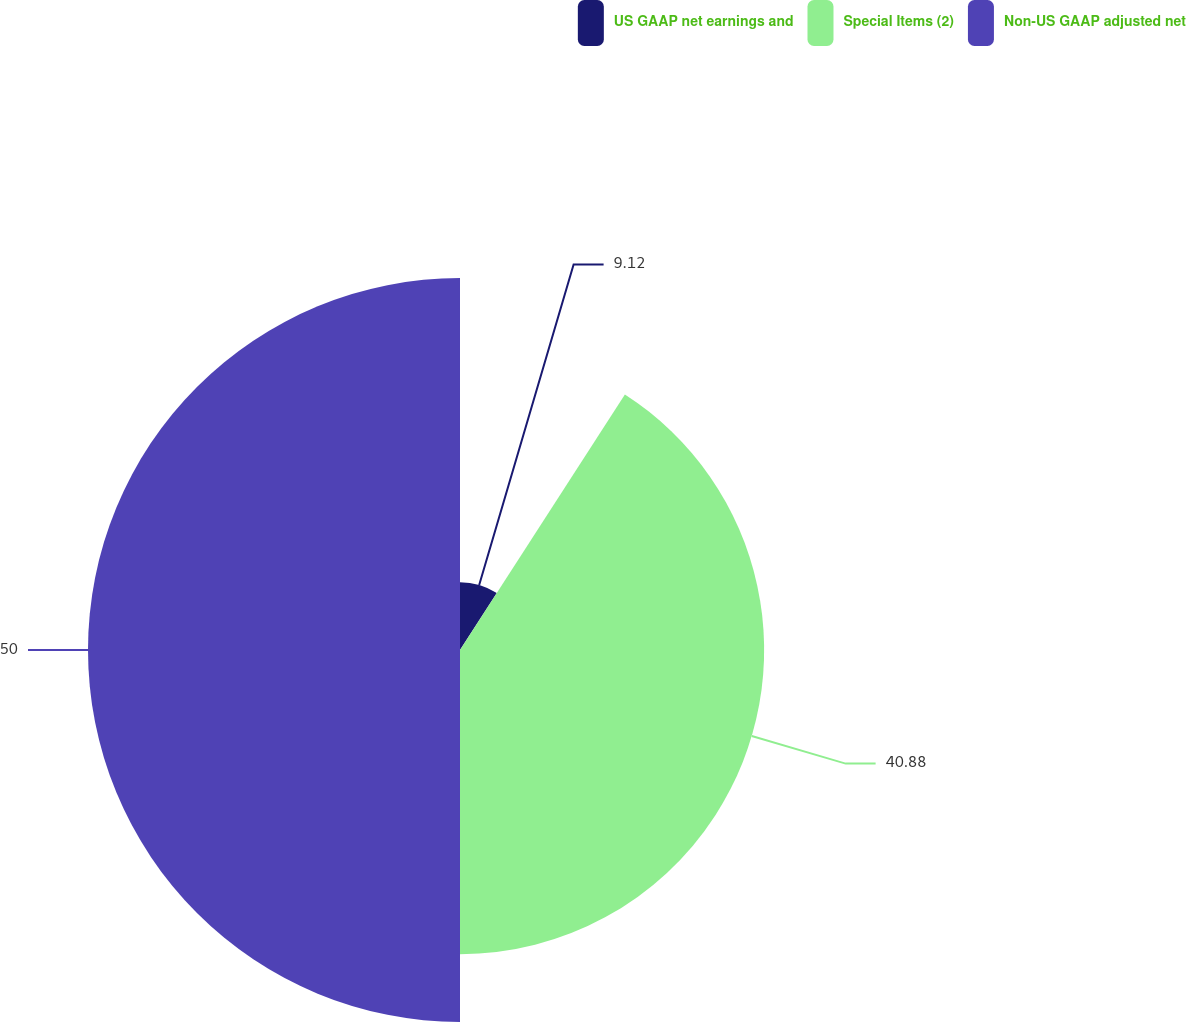Convert chart. <chart><loc_0><loc_0><loc_500><loc_500><pie_chart><fcel>US GAAP net earnings and<fcel>Special Items (2)<fcel>Non-US GAAP adjusted net<nl><fcel>9.12%<fcel>40.88%<fcel>50.0%<nl></chart> 